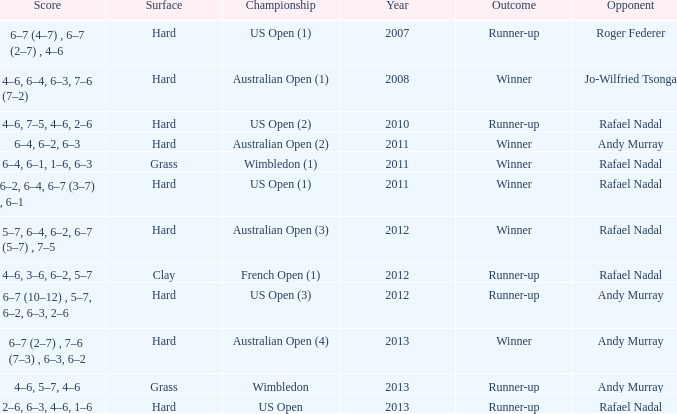What is the outcome of the 4–6, 6–4, 6–3, 7–6 (7–2) score? Winner. 